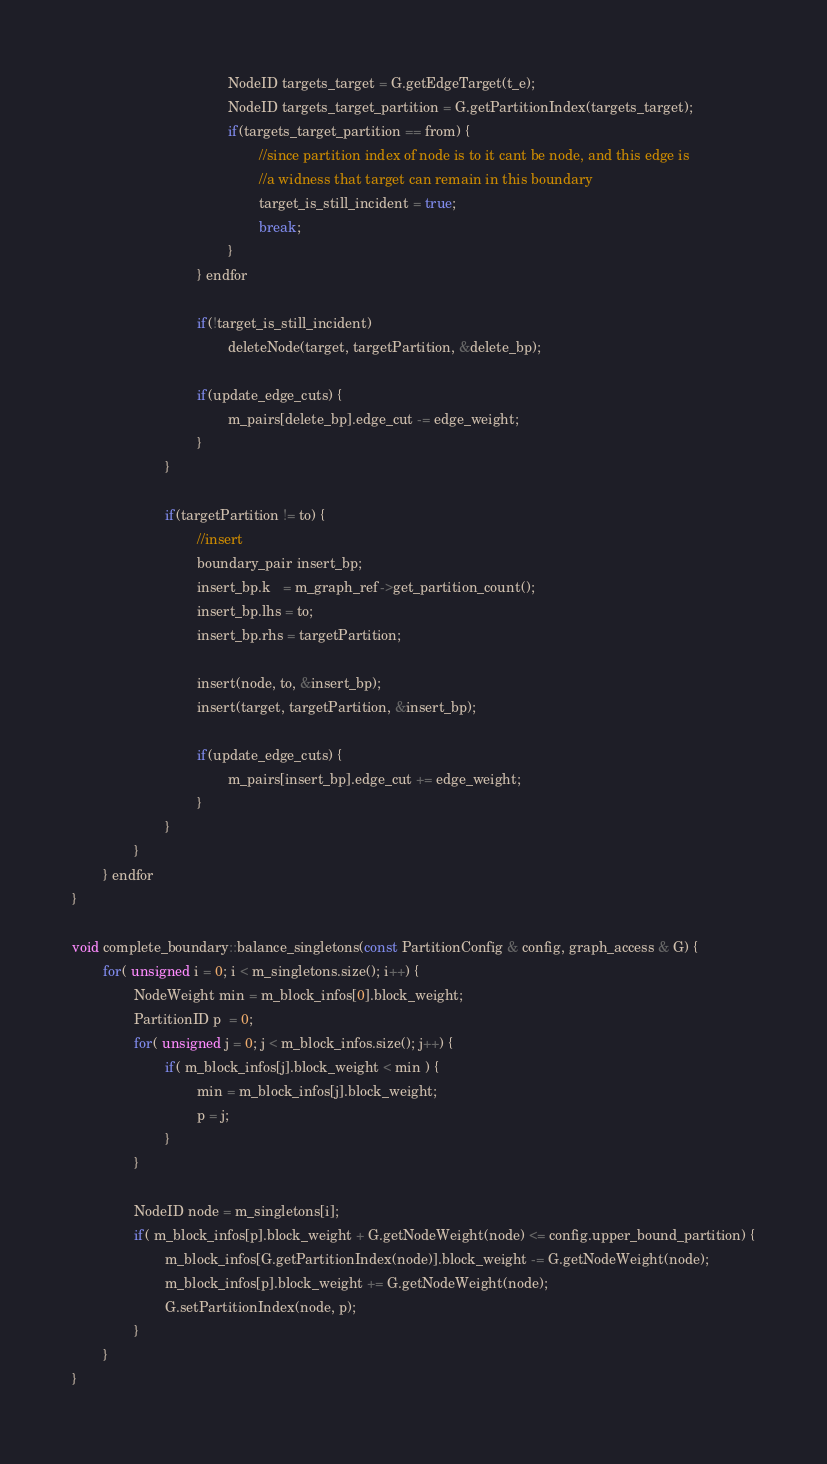Convert code to text. <code><loc_0><loc_0><loc_500><loc_500><_C++_>                                        NodeID targets_target = G.getEdgeTarget(t_e); 
                                        NodeID targets_target_partition = G.getPartitionIndex(targets_target); 
                                        if(targets_target_partition == from) {
                                                //since partition index of node is to it cant be node, and this edge is 
                                                //a widness that target can remain in this boundary
                                                target_is_still_incident = true;
                                                break;
                                        }
                                } endfor

                                if(!target_is_still_incident)
                                        deleteNode(target, targetPartition, &delete_bp);

                                if(update_edge_cuts) {
                                        m_pairs[delete_bp].edge_cut -= edge_weight;    
                                }
                        }

                        if(targetPartition != to) {
                                //insert
                                boundary_pair insert_bp;
                                insert_bp.k   = m_graph_ref->get_partition_count();
                                insert_bp.lhs = to;
                                insert_bp.rhs = targetPartition;

                                insert(node, to, &insert_bp);
                                insert(target, targetPartition, &insert_bp); 

                                if(update_edge_cuts) {
                                        m_pairs[insert_bp].edge_cut += edge_weight;    
                                }
                        }
                } 
        } endfor
}      

void complete_boundary::balance_singletons(const PartitionConfig & config, graph_access & G) {
        for( unsigned i = 0; i < m_singletons.size(); i++) {
                NodeWeight min = m_block_infos[0].block_weight;
                PartitionID p  = 0;
                for( unsigned j = 0; j < m_block_infos.size(); j++) {
                        if( m_block_infos[j].block_weight < min ) {
                                min = m_block_infos[j].block_weight;
                                p = j;
                        }
                }

                NodeID node = m_singletons[i];
                if( m_block_infos[p].block_weight + G.getNodeWeight(node) <= config.upper_bound_partition) {
                        m_block_infos[G.getPartitionIndex(node)].block_weight -= G.getNodeWeight(node);
                        m_block_infos[p].block_weight += G.getNodeWeight(node);
                        G.setPartitionIndex(node, p);
                }
        }
}
</code> 